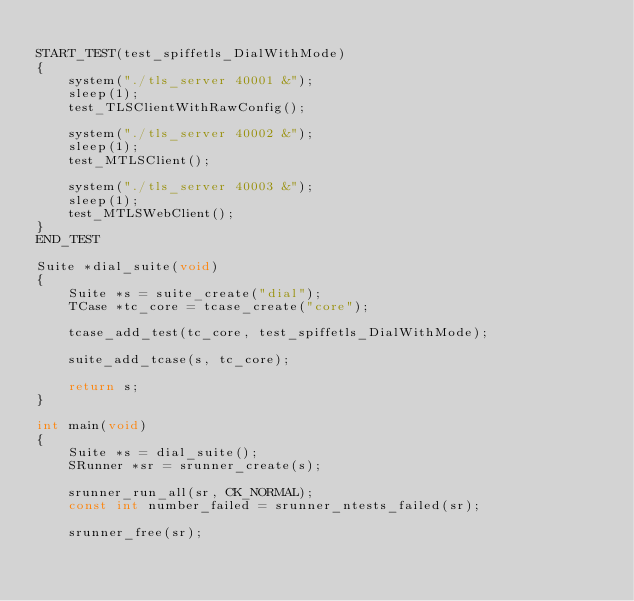Convert code to text. <code><loc_0><loc_0><loc_500><loc_500><_C_>
START_TEST(test_spiffetls_DialWithMode)
{
    system("./tls_server 40001 &");
    sleep(1);
    test_TLSClientWithRawConfig();

    system("./tls_server 40002 &");
    sleep(1);
    test_MTLSClient();

    system("./tls_server 40003 &");
    sleep(1);
    test_MTLSWebClient();
}
END_TEST

Suite *dial_suite(void)
{
    Suite *s = suite_create("dial");
    TCase *tc_core = tcase_create("core");

    tcase_add_test(tc_core, test_spiffetls_DialWithMode);

    suite_add_tcase(s, tc_core);

    return s;
}

int main(void)
{
    Suite *s = dial_suite();
    SRunner *sr = srunner_create(s);

    srunner_run_all(sr, CK_NORMAL);
    const int number_failed = srunner_ntests_failed(sr);

    srunner_free(sr);
</code> 